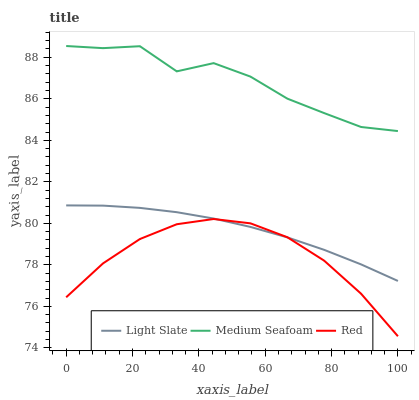Does Red have the minimum area under the curve?
Answer yes or no. Yes. Does Medium Seafoam have the maximum area under the curve?
Answer yes or no. Yes. Does Medium Seafoam have the minimum area under the curve?
Answer yes or no. No. Does Red have the maximum area under the curve?
Answer yes or no. No. Is Light Slate the smoothest?
Answer yes or no. Yes. Is Medium Seafoam the roughest?
Answer yes or no. Yes. Is Red the smoothest?
Answer yes or no. No. Is Red the roughest?
Answer yes or no. No. Does Red have the lowest value?
Answer yes or no. Yes. Does Medium Seafoam have the lowest value?
Answer yes or no. No. Does Medium Seafoam have the highest value?
Answer yes or no. Yes. Does Red have the highest value?
Answer yes or no. No. Is Red less than Medium Seafoam?
Answer yes or no. Yes. Is Medium Seafoam greater than Light Slate?
Answer yes or no. Yes. Does Light Slate intersect Red?
Answer yes or no. Yes. Is Light Slate less than Red?
Answer yes or no. No. Is Light Slate greater than Red?
Answer yes or no. No. Does Red intersect Medium Seafoam?
Answer yes or no. No. 